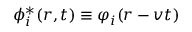<formula> <loc_0><loc_0><loc_500><loc_500>\phi _ { i } ^ { * } ( r , t ) \equiv \varphi _ { i } ( r - v t )</formula> 